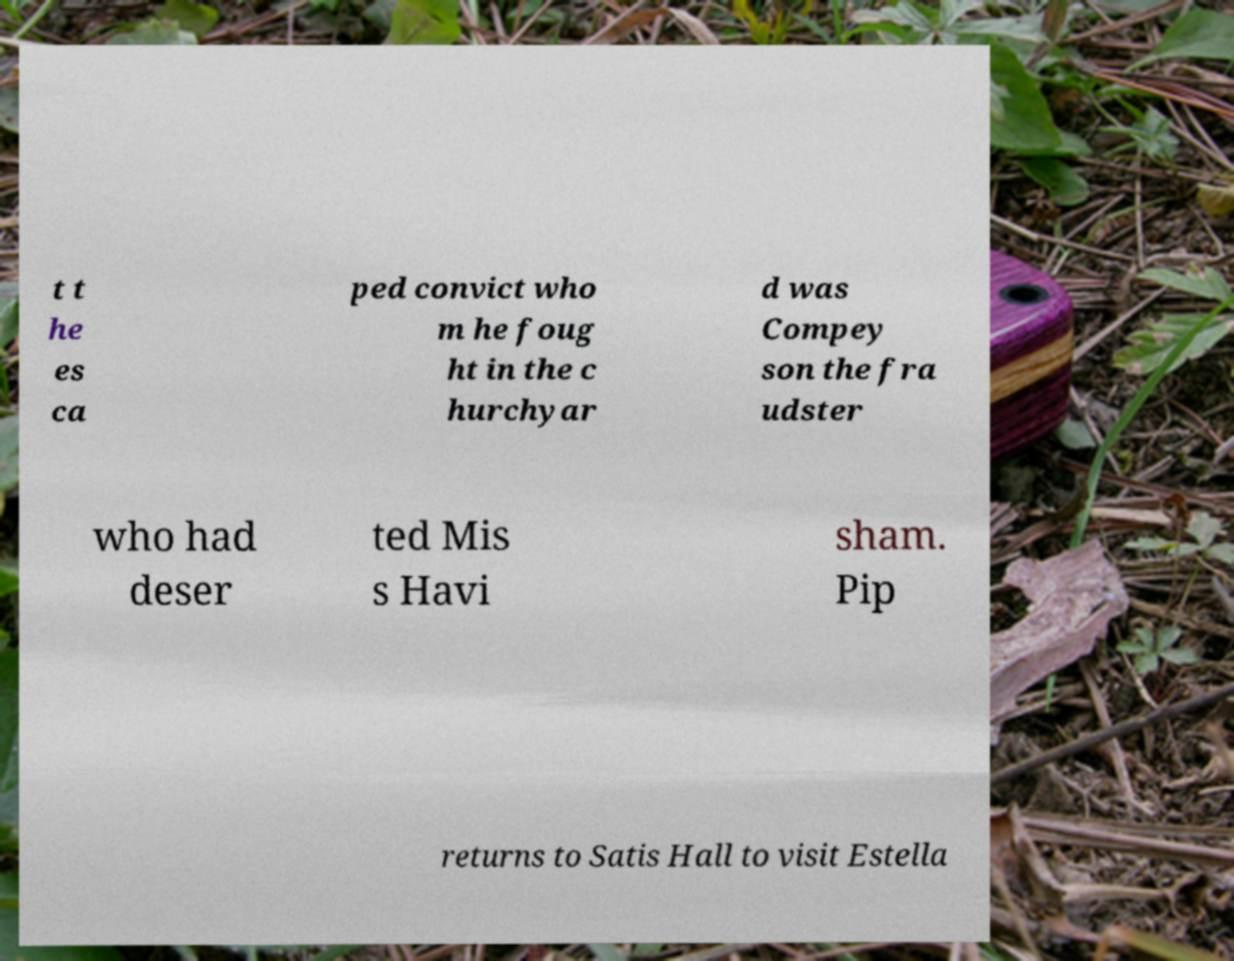For documentation purposes, I need the text within this image transcribed. Could you provide that? t t he es ca ped convict who m he foug ht in the c hurchyar d was Compey son the fra udster who had deser ted Mis s Havi sham. Pip returns to Satis Hall to visit Estella 